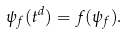<formula> <loc_0><loc_0><loc_500><loc_500>\psi _ { f } ( t ^ { d } ) = f ( \psi _ { f } ) .</formula> 